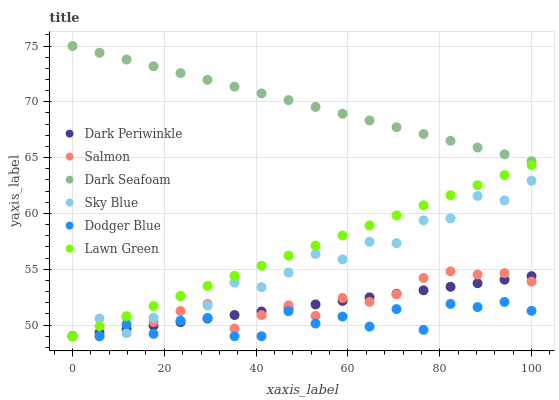Does Dodger Blue have the minimum area under the curve?
Answer yes or no. Yes. Does Dark Seafoam have the maximum area under the curve?
Answer yes or no. Yes. Does Salmon have the minimum area under the curve?
Answer yes or no. No. Does Salmon have the maximum area under the curve?
Answer yes or no. No. Is Dark Seafoam the smoothest?
Answer yes or no. Yes. Is Dodger Blue the roughest?
Answer yes or no. Yes. Is Salmon the smoothest?
Answer yes or no. No. Is Salmon the roughest?
Answer yes or no. No. Does Lawn Green have the lowest value?
Answer yes or no. Yes. Does Dark Seafoam have the lowest value?
Answer yes or no. No. Does Dark Seafoam have the highest value?
Answer yes or no. Yes. Does Salmon have the highest value?
Answer yes or no. No. Is Lawn Green less than Dark Seafoam?
Answer yes or no. Yes. Is Dark Seafoam greater than Lawn Green?
Answer yes or no. Yes. Does Dodger Blue intersect Sky Blue?
Answer yes or no. Yes. Is Dodger Blue less than Sky Blue?
Answer yes or no. No. Is Dodger Blue greater than Sky Blue?
Answer yes or no. No. Does Lawn Green intersect Dark Seafoam?
Answer yes or no. No. 